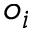Convert formula to latex. <formula><loc_0><loc_0><loc_500><loc_500>o _ { i }</formula> 